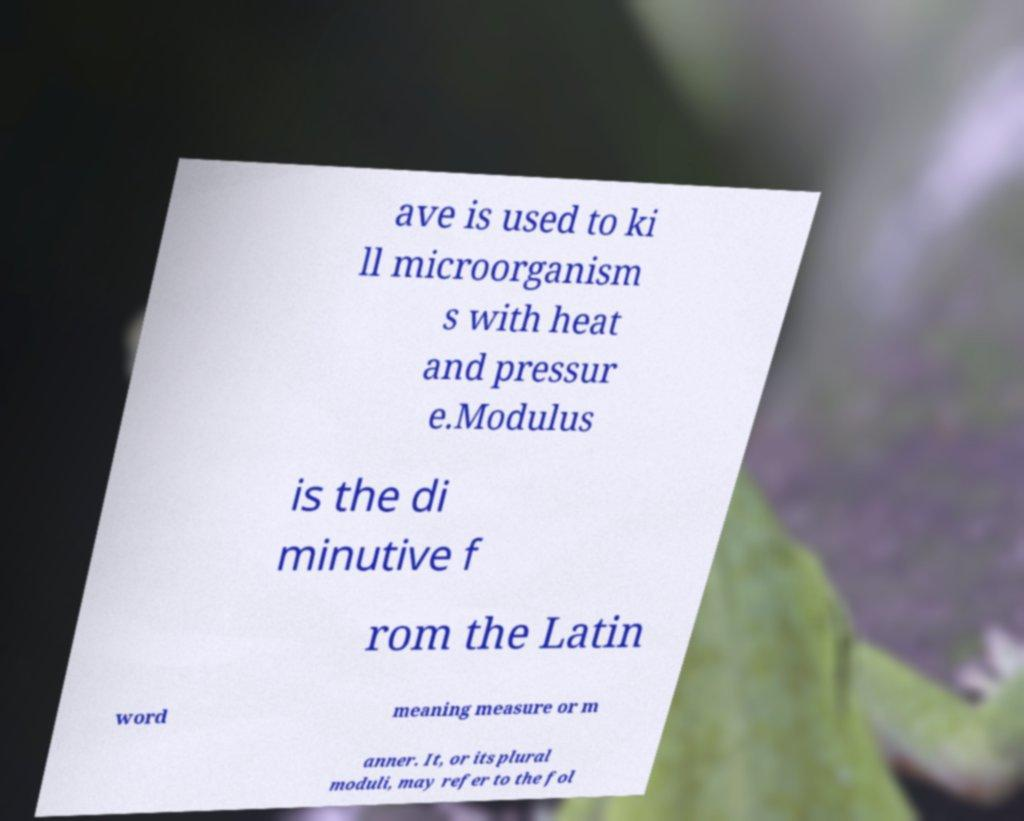Please identify and transcribe the text found in this image. ave is used to ki ll microorganism s with heat and pressur e.Modulus is the di minutive f rom the Latin word meaning measure or m anner. It, or its plural moduli, may refer to the fol 